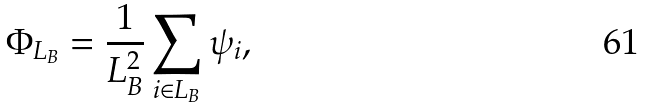<formula> <loc_0><loc_0><loc_500><loc_500>\Phi _ { L _ { B } } = \frac { 1 } { L _ { B } ^ { 2 } } \sum _ { i \in L _ { B } } \psi _ { i } ,</formula> 